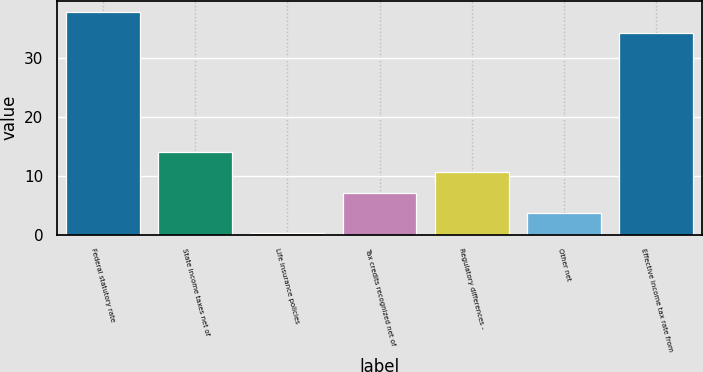Convert chart to OTSL. <chart><loc_0><loc_0><loc_500><loc_500><bar_chart><fcel>Federal statutory rate<fcel>State income taxes net of<fcel>Life insurance policies<fcel>Tax credits recognized net of<fcel>Regulatory differences -<fcel>Other net<fcel>Effective income tax rate from<nl><fcel>37.88<fcel>14.12<fcel>0.2<fcel>7.16<fcel>10.64<fcel>3.68<fcel>34.4<nl></chart> 